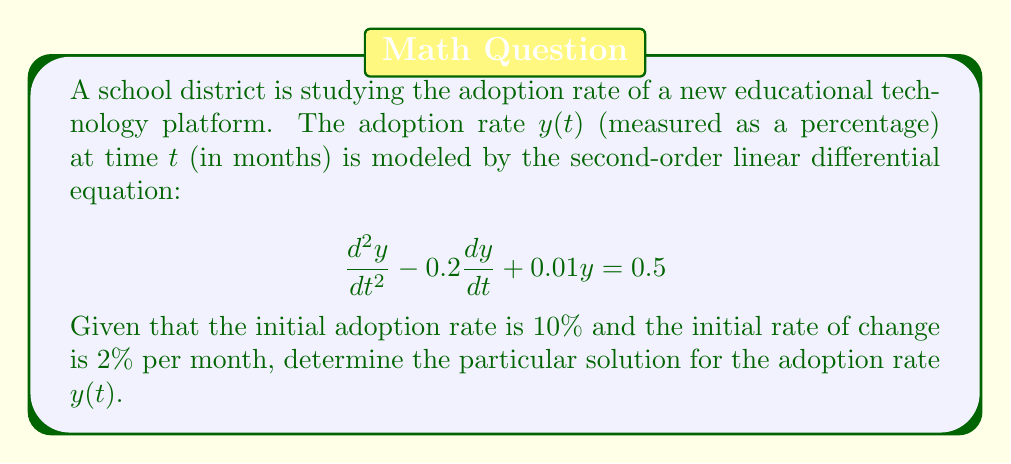What is the answer to this math problem? To solve this second-order linear differential equation, we'll follow these steps:

1) First, we need to find the general solution of the homogeneous equation:
   $$\frac{d^2y}{dt^2} - 0.2\frac{dy}{dt} + 0.01y = 0$$

   The characteristic equation is:
   $$r^2 - 0.2r + 0.01 = 0$$

   Solving this quadratic equation:
   $$r = \frac{0.2 \pm \sqrt{0.04 - 0.04}}{2} = 0.1$$

   Since we have a repeated root, the general solution of the homogeneous equation is:
   $$y_h(t) = c_1e^{0.1t} + c_2te^{0.1t}$$

2) Now, we need to find a particular solution. Given the constant right-hand side, we can assume a constant particular solution:
   $$y_p = A$$

   Substituting this into the original equation:
   $$0 - 0 + 0.01A = 0.5$$
   $$A = 50$$

3) The general solution is the sum of the homogeneous and particular solutions:
   $$y(t) = c_1e^{0.1t} + c_2te^{0.1t} + 50$$

4) To find $c_1$ and $c_2$, we use the initial conditions:
   $y(0) = 10$ and $y'(0) = 2$

   From $y(0) = 10$:
   $$10 = c_1 + 50$$
   $$c_1 = -40$$

   From $y'(t) = 0.1c_1e^{0.1t} + c_2e^{0.1t} + 0.1c_2te^{0.1t}$, we get $y'(0) = 2$:
   $$2 = 0.1c_1 + c_2$$
   $$2 = 0.1(-40) + c_2$$
   $$c_2 = 6$$

5) Therefore, the particular solution is:
   $$y(t) = -40e^{0.1t} + 6te^{0.1t} + 50$$
Answer: $y(t) = -40e^{0.1t} + 6te^{0.1t} + 50$ 